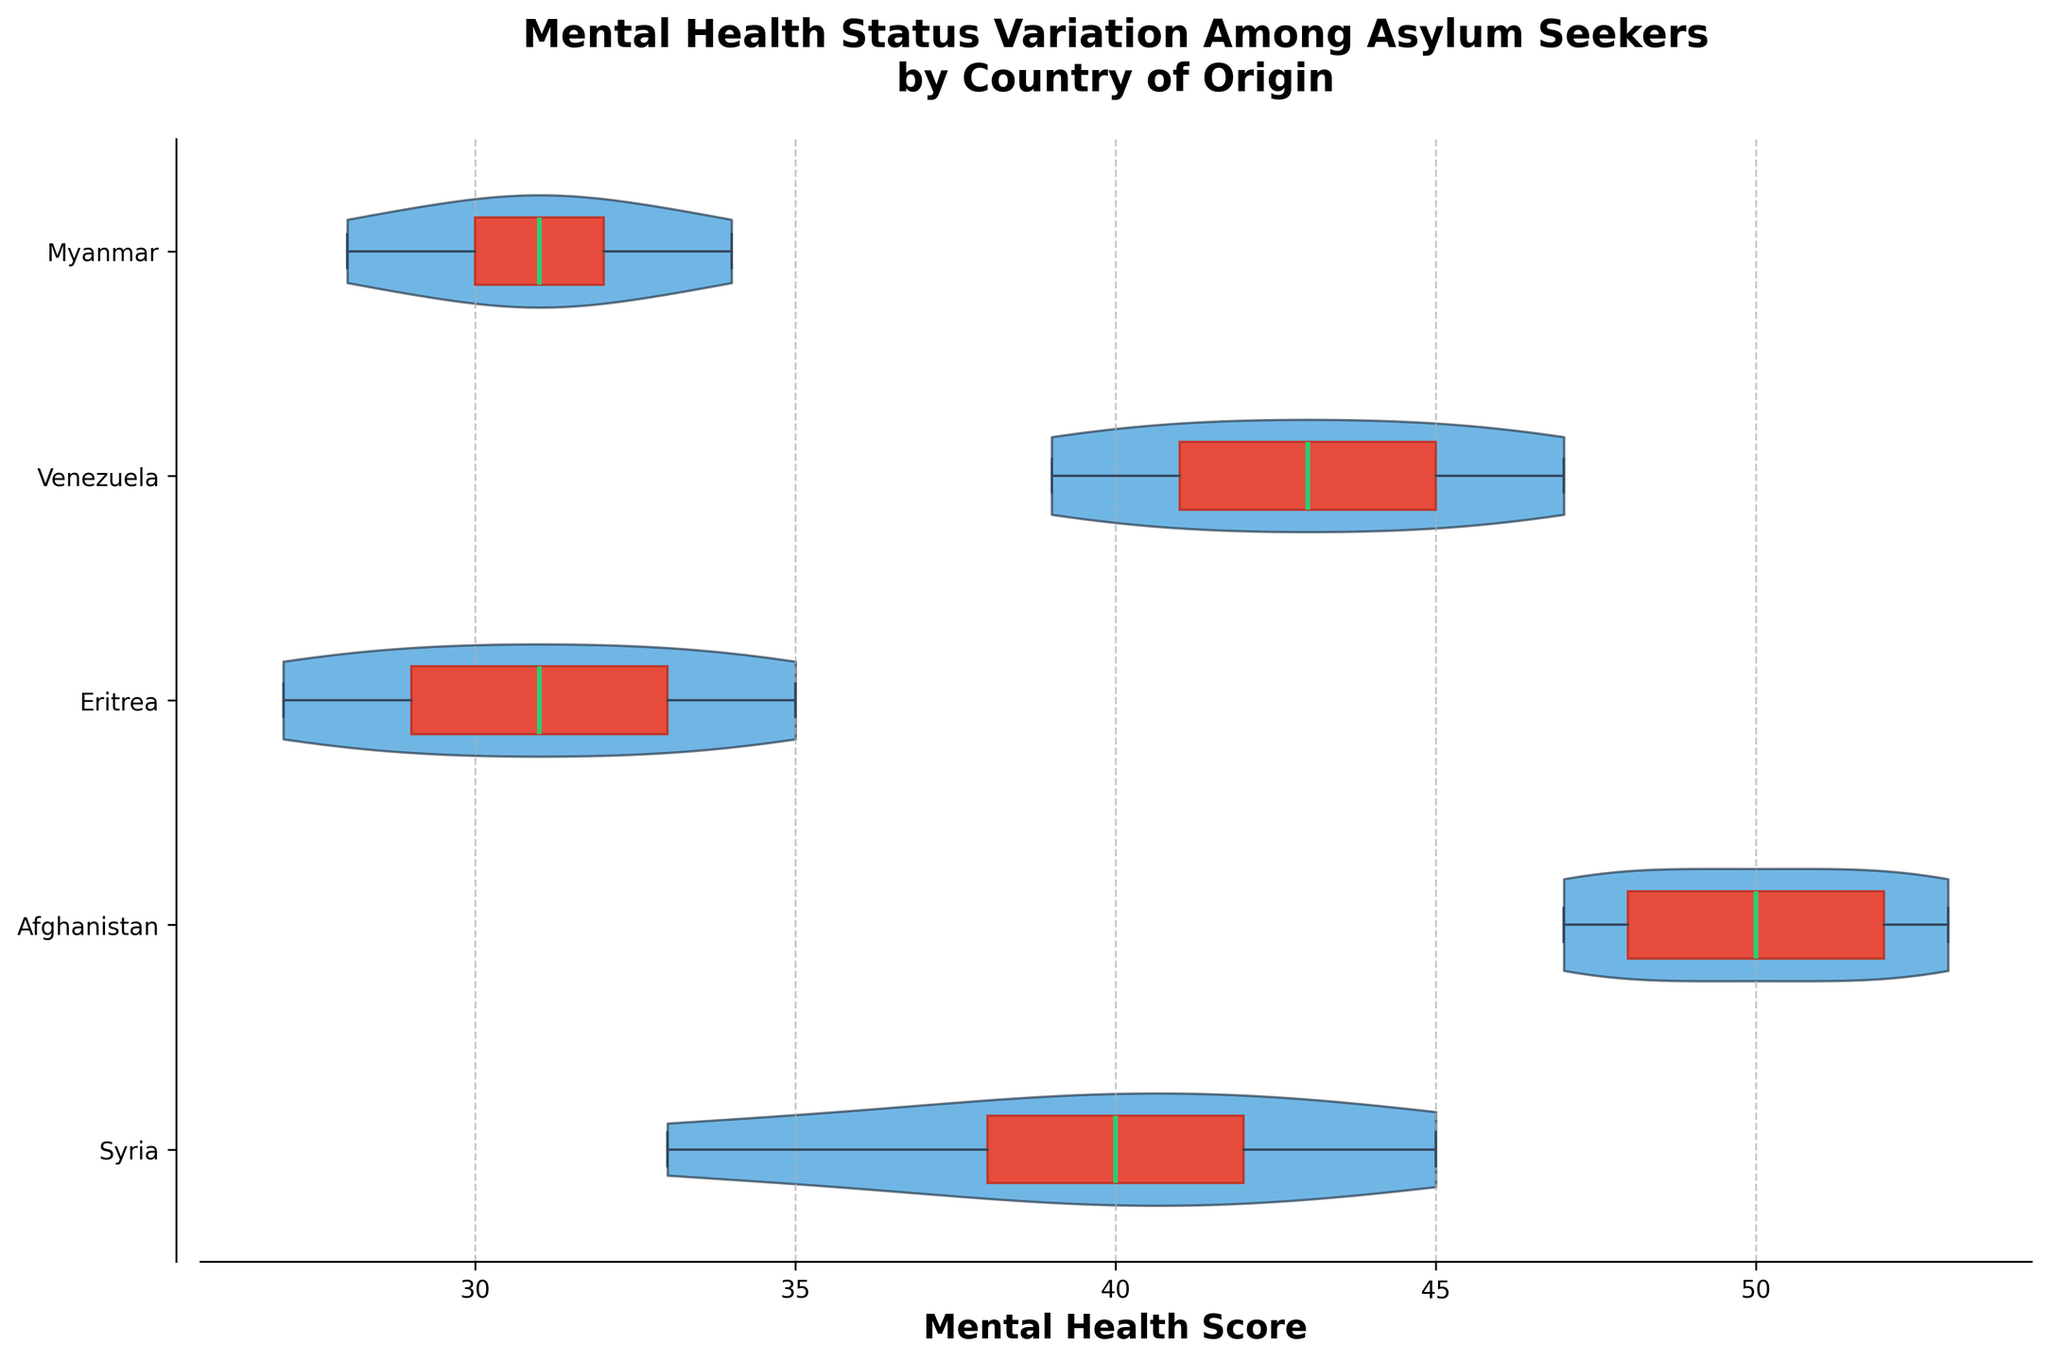What's the title of the figure? The title is written in large bold font at the top of the figure, which is designed to give an overview of the data presented.
Answer: "Mental Health Status Variation Among Asylum Seekers by Country of Origin" What does the x-axis represent? The x-axis label clearly indicates what it represents in the figure.
Answer: Mental Health Score Which country has the highest median mental health score? To find the highest median, observe the median lines inside the box plots of each violin. Afghanistan's median line is the highest on the x-axis.
Answer: Afghanistan Which group has the lowest median mental health score? Look at the median lines within the boxes in each violin plot. The Eritrea group has the lowest median, appearing furthest to the left on the x-axis.
Answer: Eritrea What is the range of scores for asylum seekers from Syria? The range is from the lowest to the highest point in the violin plot for Syria.
Answer: 33 to 45 How do the interquartile ranges (IQRs) compare between Venezuela and Myanmar? The IQR is the range between the lower and upper quartiles in the box plot. Venezuela's IQR appears wider than Myanmar's because its box is longer along the x-axis.
Answer: Venezuela has a wider IQR than Myanmar Describe the overall distribution shape for Eritrea. The violin plot shape indicates the distribution of the data points. Eritrea has a relatively elongated shape with much of the density towards the lower end, indicating more frequent lower scores.
Answer: Skewed left with majority low scores How does the mental health score variation of asylum seekers from Myanmar compare to that of Syria? Compare the widths and spans of both violins: Myanmar's violin is narrower and less spread out, indicating less variation compared to Syria's violin, which is wider and more spread out.
Answer: Less variation in Myanmar than in Syria Which country of origin has the most symmetrical distribution? Examine the symmetry of the violin plots. Afghanistan's distribution appears most symmetrical around its median.
Answer: Afghanistan What does the distribution of Mental Health Scores look like across all countries? The distributions can be visualized using the violin shapes and box plots. Afghanistan and Venezuela display more evenly distributed and higher scores, while Eritrea has more lower scores. This indicates variation in mental health status across different origins.
Answer: Varied distributions with noticeable higher scores in Afghanistan and Venezuela, lower scores in Eritrea 